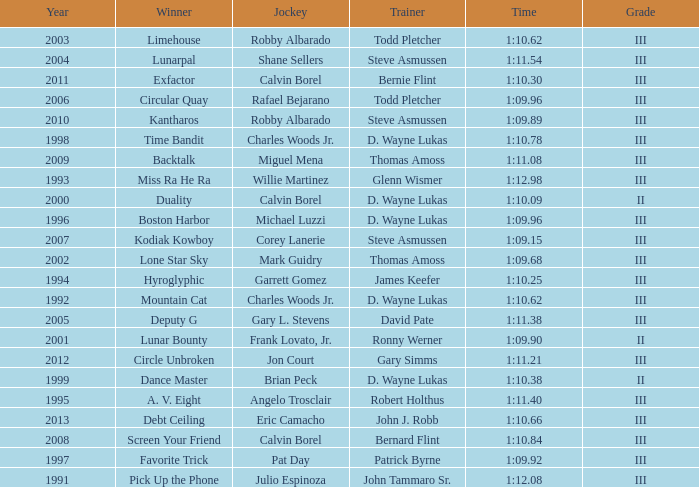Which trainer won the hyroglyphic in a year that was before 2010? James Keefer. 